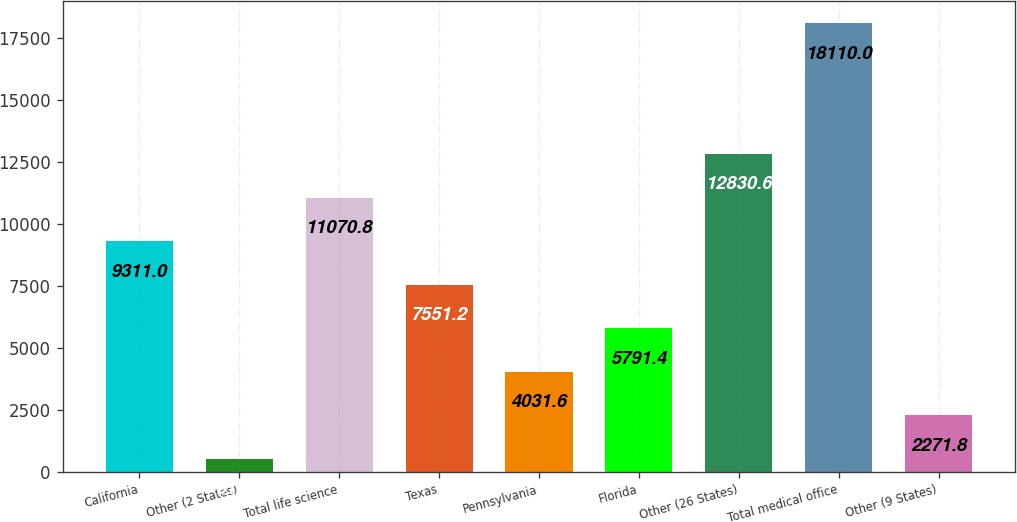Convert chart to OTSL. <chart><loc_0><loc_0><loc_500><loc_500><bar_chart><fcel>California<fcel>Other (2 States)<fcel>Total life science<fcel>Texas<fcel>Pennsylvania<fcel>Florida<fcel>Other (26 States)<fcel>Total medical office<fcel>Other (9 States)<nl><fcel>9311<fcel>512<fcel>11070.8<fcel>7551.2<fcel>4031.6<fcel>5791.4<fcel>12830.6<fcel>18110<fcel>2271.8<nl></chart> 